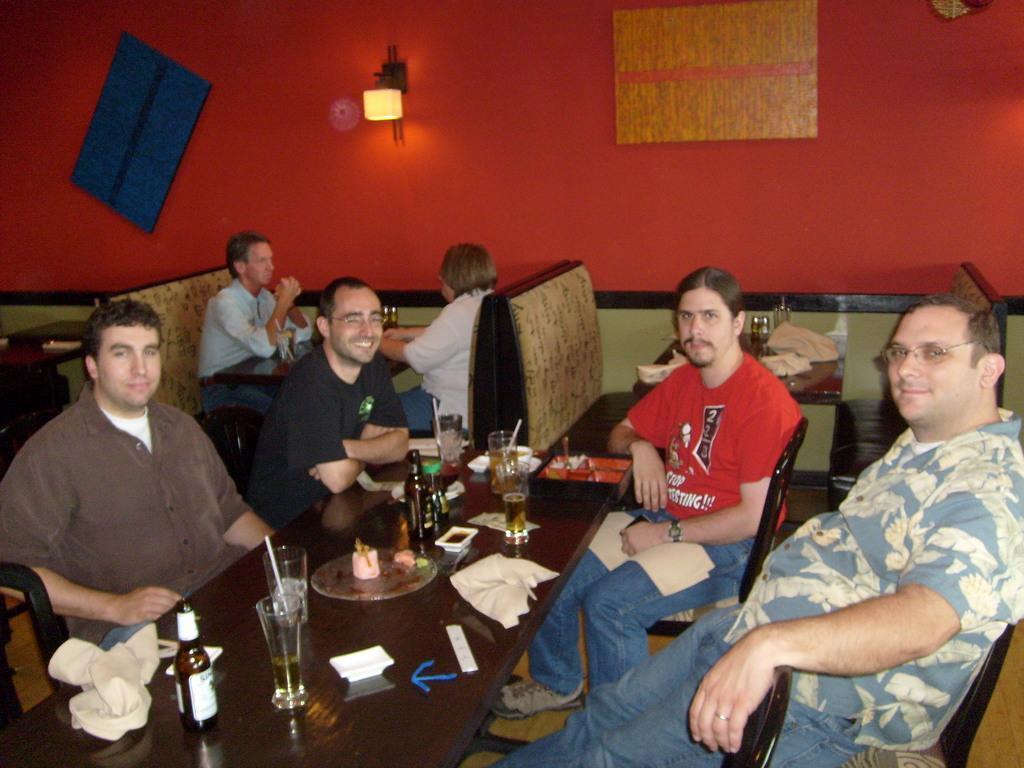What are the people in the image doing? The people in the image are sitting on chairs. What can be seen on the table in the image? There are wine bottles and wine glasses on the table. Are there any other people visible in the image? Yes, there are other people sitting in the background of the image. What type of net is being used by the people in the image? There is no net present in the image; the people are sitting on chairs and there are wine bottles and glasses on the table. 